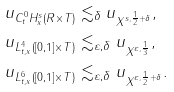Convert formula to latex. <formula><loc_0><loc_0><loc_500><loc_500>\| u \| _ { C ^ { 0 } _ { t } H ^ { s } _ { x } ( R \times T ) } & \lesssim _ { \delta } \| u \| _ { X ^ { s , \frac { 1 } { 2 } + \delta } } , \\ \| u \| _ { L ^ { 4 } _ { t , x } ( [ 0 , 1 ] \times T ) } & \lesssim _ { \varepsilon , \delta } \| u \| _ { X ^ { \varepsilon , \frac { 1 } { 3 } } } , \\ \| u \| _ { L ^ { 6 } _ { t , x } ( [ 0 , 1 ] \times T ) } & \lesssim _ { \varepsilon , \delta } \| u \| _ { X ^ { \varepsilon , \frac { 1 } { 2 } + \delta } } .</formula> 